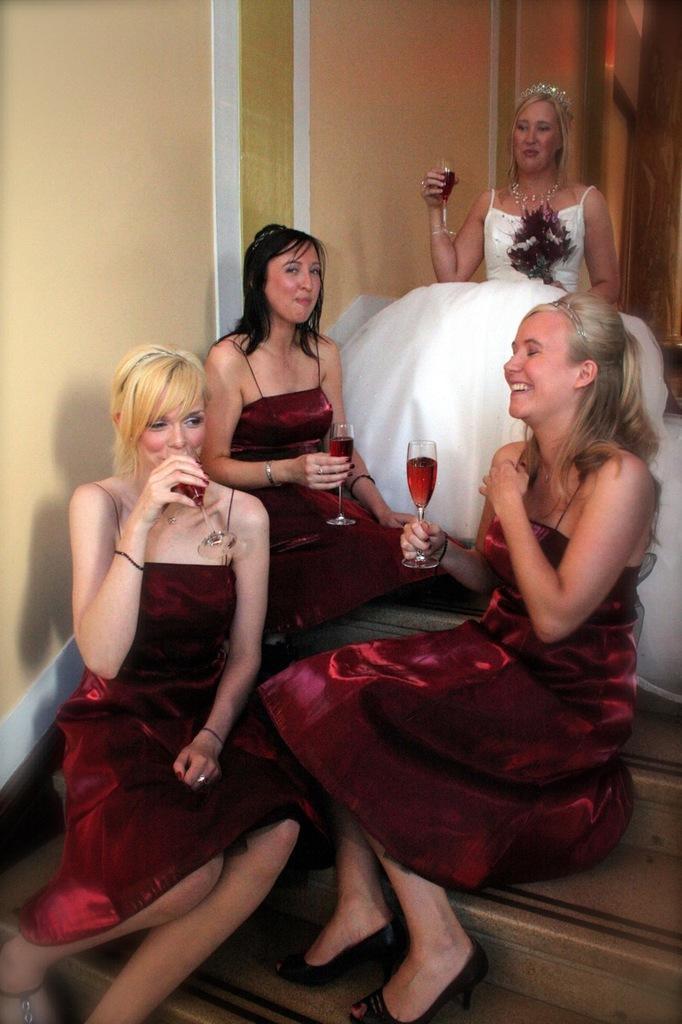In one or two sentences, can you explain what this image depicts? In this image we can see there is an inside view of the building. And there are people sitting on the stairs and holding a glass to drink. 